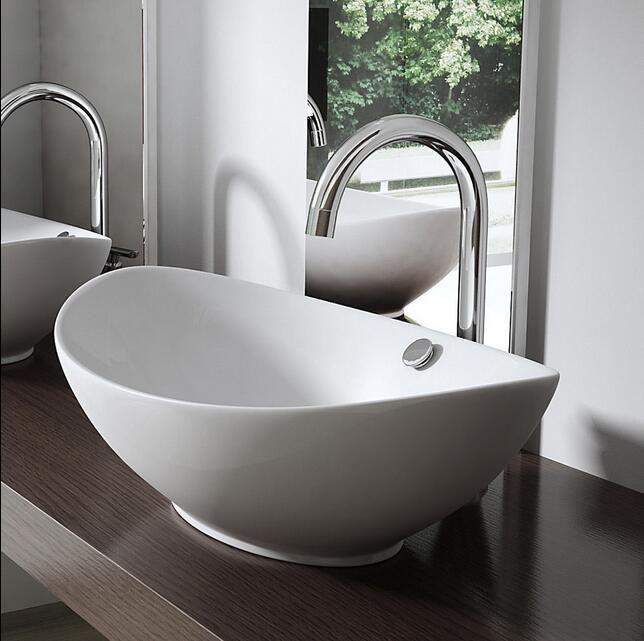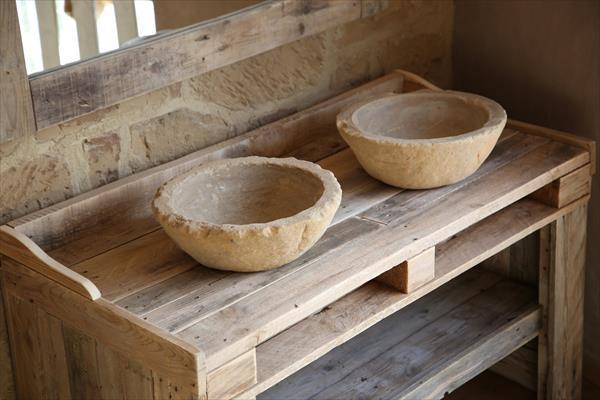The first image is the image on the left, the second image is the image on the right. Examine the images to the left and right. Is the description "In one image a round white sink with dark faucets and curved spout is set into a wooden-topped bathroom vanity." accurate? Answer yes or no. No. The first image is the image on the left, the second image is the image on the right. Analyze the images presented: Is the assertion "The sink in the image on the right is set in the counter." valid? Answer yes or no. No. 